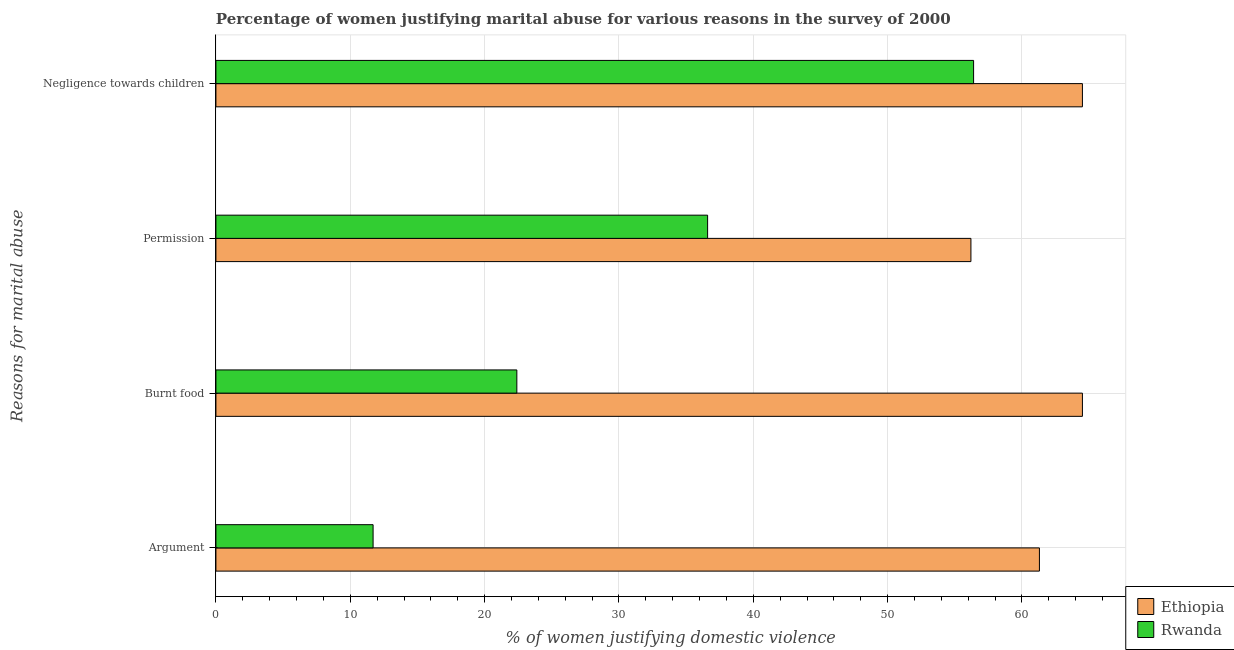How many groups of bars are there?
Ensure brevity in your answer.  4. How many bars are there on the 1st tick from the top?
Your answer should be compact. 2. What is the label of the 2nd group of bars from the top?
Your answer should be compact. Permission. Across all countries, what is the maximum percentage of women justifying abuse for burning food?
Give a very brief answer. 64.5. Across all countries, what is the minimum percentage of women justifying abuse for burning food?
Make the answer very short. 22.4. In which country was the percentage of women justifying abuse for burning food maximum?
Make the answer very short. Ethiopia. In which country was the percentage of women justifying abuse for going without permission minimum?
Ensure brevity in your answer.  Rwanda. What is the total percentage of women justifying abuse in the case of an argument in the graph?
Provide a succinct answer. 73. What is the difference between the percentage of women justifying abuse in the case of an argument in Rwanda and that in Ethiopia?
Provide a succinct answer. -49.6. What is the difference between the percentage of women justifying abuse in the case of an argument in Rwanda and the percentage of women justifying abuse for burning food in Ethiopia?
Give a very brief answer. -52.8. What is the average percentage of women justifying abuse in the case of an argument per country?
Ensure brevity in your answer.  36.5. In how many countries, is the percentage of women justifying abuse for burning food greater than 18 %?
Offer a very short reply. 2. What is the ratio of the percentage of women justifying abuse for showing negligence towards children in Rwanda to that in Ethiopia?
Your response must be concise. 0.87. Is the difference between the percentage of women justifying abuse for burning food in Rwanda and Ethiopia greater than the difference between the percentage of women justifying abuse for showing negligence towards children in Rwanda and Ethiopia?
Ensure brevity in your answer.  No. What is the difference between the highest and the second highest percentage of women justifying abuse for burning food?
Ensure brevity in your answer.  42.1. What is the difference between the highest and the lowest percentage of women justifying abuse for showing negligence towards children?
Your answer should be very brief. 8.1. Is the sum of the percentage of women justifying abuse in the case of an argument in Ethiopia and Rwanda greater than the maximum percentage of women justifying abuse for showing negligence towards children across all countries?
Keep it short and to the point. Yes. Is it the case that in every country, the sum of the percentage of women justifying abuse in the case of an argument and percentage of women justifying abuse for burning food is greater than the sum of percentage of women justifying abuse for showing negligence towards children and percentage of women justifying abuse for going without permission?
Make the answer very short. No. What does the 2nd bar from the top in Argument represents?
Keep it short and to the point. Ethiopia. What does the 1st bar from the bottom in Permission represents?
Your answer should be very brief. Ethiopia. Is it the case that in every country, the sum of the percentage of women justifying abuse in the case of an argument and percentage of women justifying abuse for burning food is greater than the percentage of women justifying abuse for going without permission?
Provide a succinct answer. No. How many bars are there?
Make the answer very short. 8. Are all the bars in the graph horizontal?
Provide a short and direct response. Yes. How many countries are there in the graph?
Provide a short and direct response. 2. What is the difference between two consecutive major ticks on the X-axis?
Provide a short and direct response. 10. Are the values on the major ticks of X-axis written in scientific E-notation?
Make the answer very short. No. Does the graph contain any zero values?
Your answer should be compact. No. Does the graph contain grids?
Make the answer very short. Yes. How many legend labels are there?
Provide a succinct answer. 2. How are the legend labels stacked?
Provide a succinct answer. Vertical. What is the title of the graph?
Ensure brevity in your answer.  Percentage of women justifying marital abuse for various reasons in the survey of 2000. Does "Guam" appear as one of the legend labels in the graph?
Your answer should be very brief. No. What is the label or title of the X-axis?
Provide a succinct answer. % of women justifying domestic violence. What is the label or title of the Y-axis?
Ensure brevity in your answer.  Reasons for marital abuse. What is the % of women justifying domestic violence in Ethiopia in Argument?
Your response must be concise. 61.3. What is the % of women justifying domestic violence of Rwanda in Argument?
Provide a succinct answer. 11.7. What is the % of women justifying domestic violence in Ethiopia in Burnt food?
Ensure brevity in your answer.  64.5. What is the % of women justifying domestic violence of Rwanda in Burnt food?
Provide a short and direct response. 22.4. What is the % of women justifying domestic violence in Ethiopia in Permission?
Make the answer very short. 56.2. What is the % of women justifying domestic violence of Rwanda in Permission?
Provide a short and direct response. 36.6. What is the % of women justifying domestic violence in Ethiopia in Negligence towards children?
Keep it short and to the point. 64.5. What is the % of women justifying domestic violence in Rwanda in Negligence towards children?
Offer a terse response. 56.4. Across all Reasons for marital abuse, what is the maximum % of women justifying domestic violence in Ethiopia?
Ensure brevity in your answer.  64.5. Across all Reasons for marital abuse, what is the maximum % of women justifying domestic violence of Rwanda?
Make the answer very short. 56.4. Across all Reasons for marital abuse, what is the minimum % of women justifying domestic violence in Ethiopia?
Keep it short and to the point. 56.2. Across all Reasons for marital abuse, what is the minimum % of women justifying domestic violence of Rwanda?
Provide a short and direct response. 11.7. What is the total % of women justifying domestic violence of Ethiopia in the graph?
Give a very brief answer. 246.5. What is the total % of women justifying domestic violence of Rwanda in the graph?
Offer a very short reply. 127.1. What is the difference between the % of women justifying domestic violence in Ethiopia in Argument and that in Burnt food?
Provide a short and direct response. -3.2. What is the difference between the % of women justifying domestic violence in Ethiopia in Argument and that in Permission?
Ensure brevity in your answer.  5.1. What is the difference between the % of women justifying domestic violence of Rwanda in Argument and that in Permission?
Your answer should be very brief. -24.9. What is the difference between the % of women justifying domestic violence in Ethiopia in Argument and that in Negligence towards children?
Offer a terse response. -3.2. What is the difference between the % of women justifying domestic violence in Rwanda in Argument and that in Negligence towards children?
Keep it short and to the point. -44.7. What is the difference between the % of women justifying domestic violence of Ethiopia in Burnt food and that in Negligence towards children?
Ensure brevity in your answer.  0. What is the difference between the % of women justifying domestic violence of Rwanda in Burnt food and that in Negligence towards children?
Offer a very short reply. -34. What is the difference between the % of women justifying domestic violence of Rwanda in Permission and that in Negligence towards children?
Keep it short and to the point. -19.8. What is the difference between the % of women justifying domestic violence in Ethiopia in Argument and the % of women justifying domestic violence in Rwanda in Burnt food?
Your response must be concise. 38.9. What is the difference between the % of women justifying domestic violence in Ethiopia in Argument and the % of women justifying domestic violence in Rwanda in Permission?
Your answer should be compact. 24.7. What is the difference between the % of women justifying domestic violence of Ethiopia in Burnt food and the % of women justifying domestic violence of Rwanda in Permission?
Give a very brief answer. 27.9. What is the difference between the % of women justifying domestic violence of Ethiopia in Burnt food and the % of women justifying domestic violence of Rwanda in Negligence towards children?
Provide a succinct answer. 8.1. What is the difference between the % of women justifying domestic violence of Ethiopia in Permission and the % of women justifying domestic violence of Rwanda in Negligence towards children?
Provide a succinct answer. -0.2. What is the average % of women justifying domestic violence of Ethiopia per Reasons for marital abuse?
Offer a terse response. 61.62. What is the average % of women justifying domestic violence of Rwanda per Reasons for marital abuse?
Provide a short and direct response. 31.77. What is the difference between the % of women justifying domestic violence of Ethiopia and % of women justifying domestic violence of Rwanda in Argument?
Make the answer very short. 49.6. What is the difference between the % of women justifying domestic violence of Ethiopia and % of women justifying domestic violence of Rwanda in Burnt food?
Offer a terse response. 42.1. What is the difference between the % of women justifying domestic violence of Ethiopia and % of women justifying domestic violence of Rwanda in Permission?
Offer a terse response. 19.6. What is the difference between the % of women justifying domestic violence in Ethiopia and % of women justifying domestic violence in Rwanda in Negligence towards children?
Your response must be concise. 8.1. What is the ratio of the % of women justifying domestic violence of Ethiopia in Argument to that in Burnt food?
Offer a very short reply. 0.95. What is the ratio of the % of women justifying domestic violence of Rwanda in Argument to that in Burnt food?
Your answer should be very brief. 0.52. What is the ratio of the % of women justifying domestic violence in Ethiopia in Argument to that in Permission?
Make the answer very short. 1.09. What is the ratio of the % of women justifying domestic violence of Rwanda in Argument to that in Permission?
Your answer should be very brief. 0.32. What is the ratio of the % of women justifying domestic violence in Ethiopia in Argument to that in Negligence towards children?
Offer a very short reply. 0.95. What is the ratio of the % of women justifying domestic violence of Rwanda in Argument to that in Negligence towards children?
Your answer should be very brief. 0.21. What is the ratio of the % of women justifying domestic violence in Ethiopia in Burnt food to that in Permission?
Your response must be concise. 1.15. What is the ratio of the % of women justifying domestic violence in Rwanda in Burnt food to that in Permission?
Your answer should be very brief. 0.61. What is the ratio of the % of women justifying domestic violence in Rwanda in Burnt food to that in Negligence towards children?
Give a very brief answer. 0.4. What is the ratio of the % of women justifying domestic violence in Ethiopia in Permission to that in Negligence towards children?
Keep it short and to the point. 0.87. What is the ratio of the % of women justifying domestic violence of Rwanda in Permission to that in Negligence towards children?
Ensure brevity in your answer.  0.65. What is the difference between the highest and the second highest % of women justifying domestic violence in Rwanda?
Offer a very short reply. 19.8. What is the difference between the highest and the lowest % of women justifying domestic violence in Rwanda?
Give a very brief answer. 44.7. 